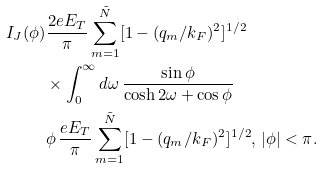Convert formula to latex. <formula><loc_0><loc_0><loc_500><loc_500>I _ { J } ( \phi ) & \frac { 2 e E _ { T } } { \pi } \sum _ { m = 1 } ^ { \tilde { N } } [ 1 - ( q _ { m } / k _ { F } ) ^ { 2 } ] ^ { 1 / 2 } \\ & \times \int _ { 0 } ^ { \infty } d \omega \, \frac { \sin \phi } { \cosh 2 \omega + \cos \phi } \\ & \phi \, \frac { e E _ { T } } { \pi } \sum _ { m = 1 } ^ { \tilde { N } } [ 1 - ( q _ { m } / k _ { F } ) ^ { 2 } ] ^ { 1 / 2 } , \, | \phi | < \pi .</formula> 